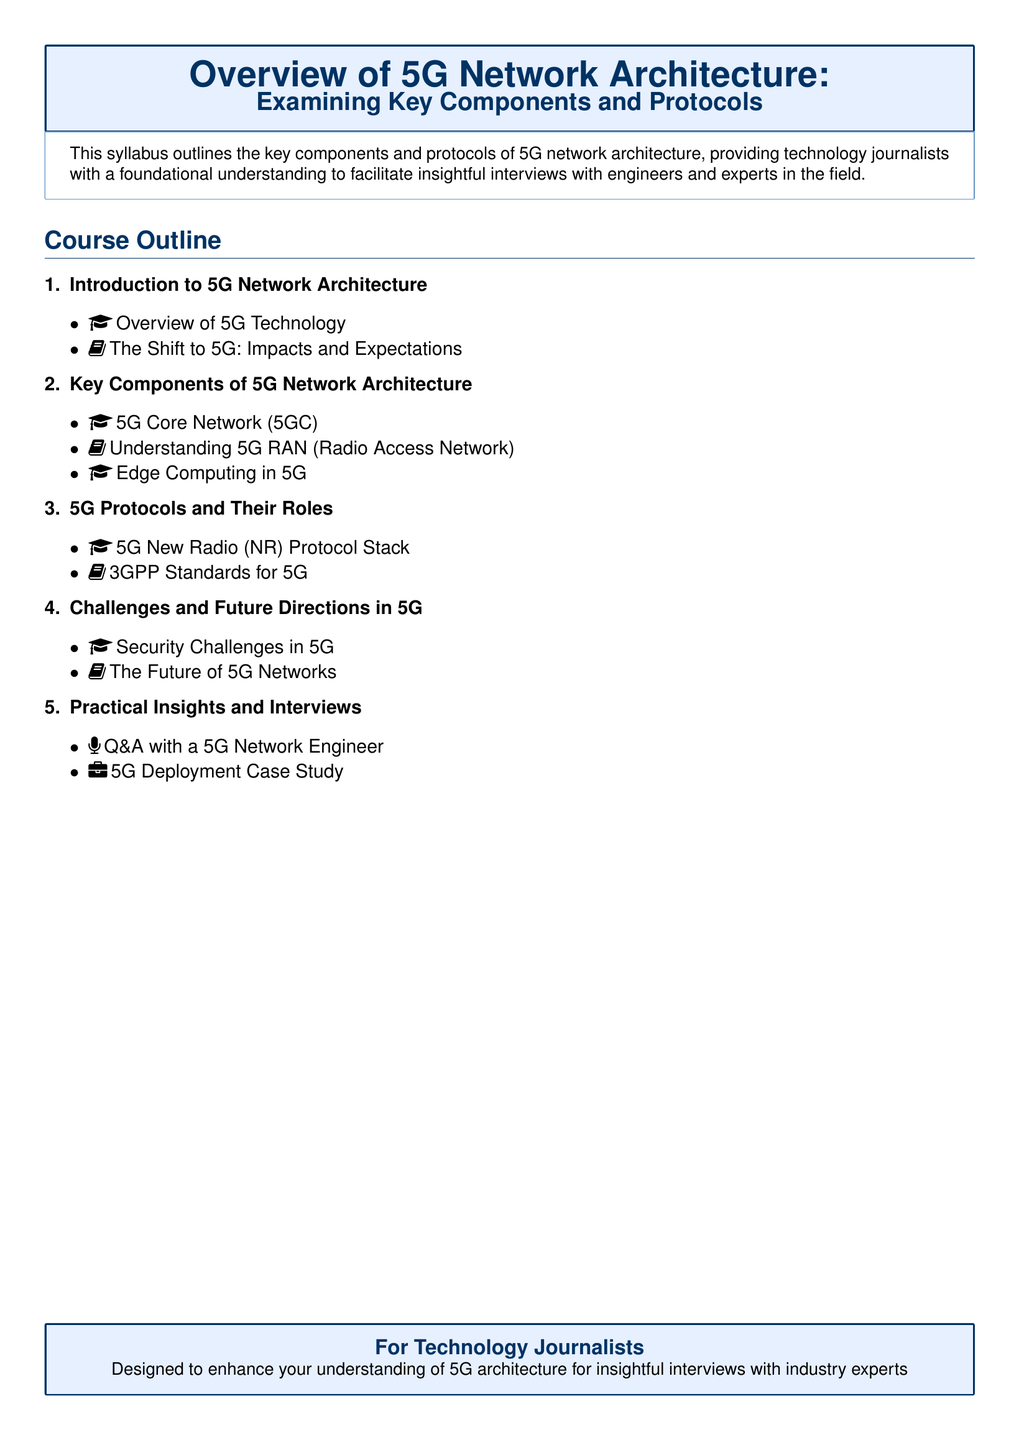What is the main focus of the syllabus? The syllabus outlines the key components and protocols of 5G network architecture.
Answer: Key components and protocols of 5G network architecture How many lectures are there in the course outline? The course outline includes five main sections, each with associated lectures.
Answer: Five What does 5G NR stand for? The acronym refers to the new radio protocol stack for 5G.
Answer: New Radio Which protocol stack is covered in the syllabus? The syllabus explicitly mentions the 5G New Radio protocol stack.
Answer: 5G New Radio (NR) Protocol Stack What is one of the security challenges mentioned in the syllabus? The syllabus includes a lecture specifically focused on security challenges in 5G.
Answer: Security Challenges in 5G What type of document is this syllabus aimed at? The syllabus is designed for technology journalists looking to enhance their understanding of 5G architecture.
Answer: Technology journalists Which organization's standards for 5G are mentioned in the document? The syllabus references 3GPP standards related to 5G.
Answer: 3GPP What section focuses on practical insights? The syllabus includes a section dedicated to practical insights and interviews.
Answer: Practical Insights and Interviews 